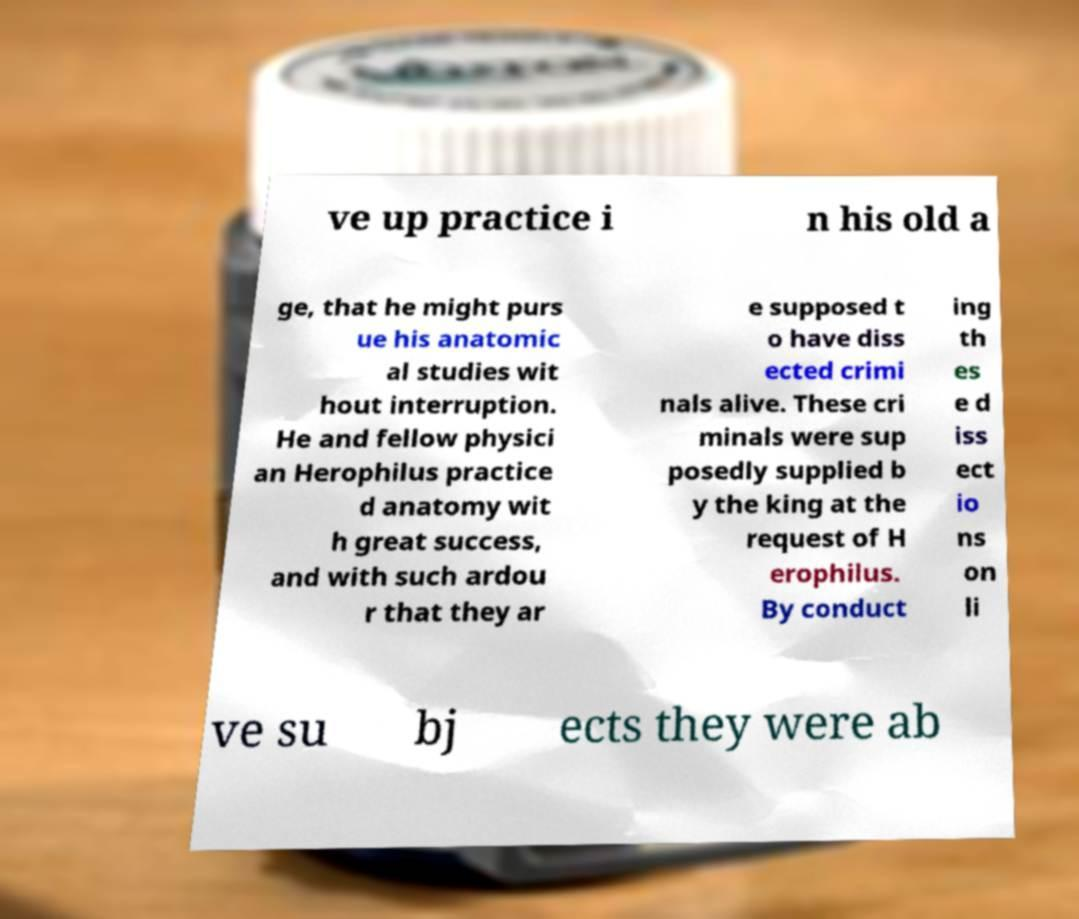Please identify and transcribe the text found in this image. ve up practice i n his old a ge, that he might purs ue his anatomic al studies wit hout interruption. He and fellow physici an Herophilus practice d anatomy wit h great success, and with such ardou r that they ar e supposed t o have diss ected crimi nals alive. These cri minals were sup posedly supplied b y the king at the request of H erophilus. By conduct ing th es e d iss ect io ns on li ve su bj ects they were ab 